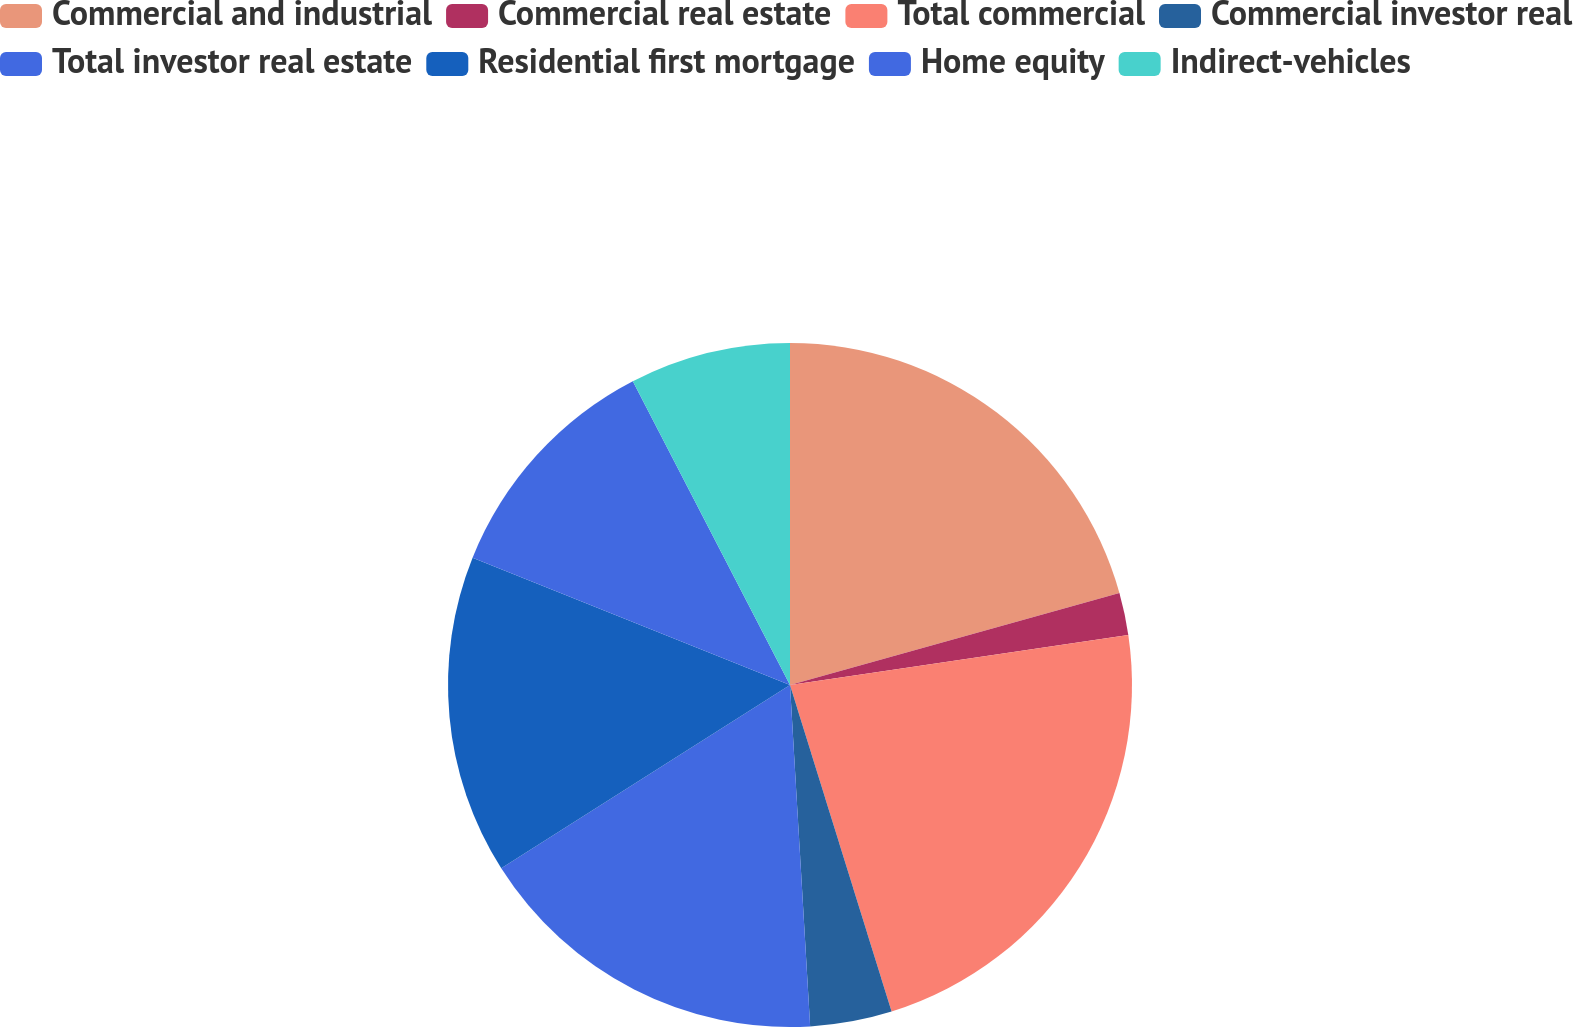<chart> <loc_0><loc_0><loc_500><loc_500><pie_chart><fcel>Commercial and industrial<fcel>Commercial real estate<fcel>Total commercial<fcel>Commercial investor real<fcel>Total investor real estate<fcel>Residential first mortgage<fcel>Home equity<fcel>Indirect-vehicles<nl><fcel>20.67%<fcel>1.99%<fcel>22.54%<fcel>3.86%<fcel>16.94%<fcel>15.07%<fcel>11.33%<fcel>7.6%<nl></chart> 